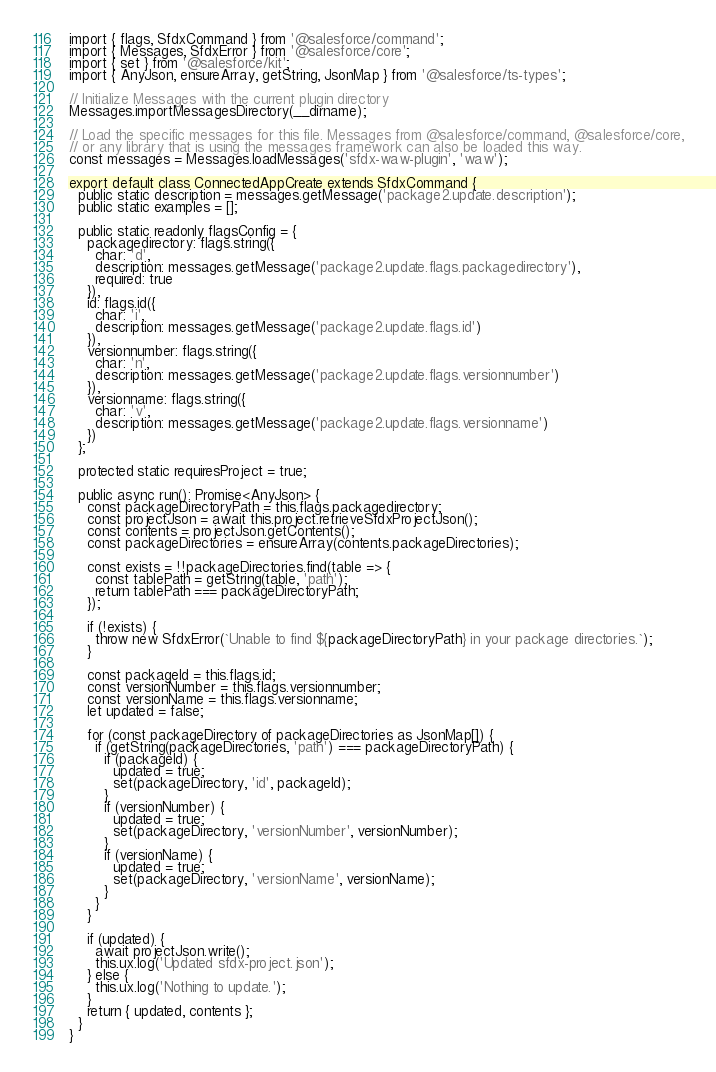<code> <loc_0><loc_0><loc_500><loc_500><_TypeScript_>import { flags, SfdxCommand } from '@salesforce/command';
import { Messages, SfdxError } from '@salesforce/core';
import { set } from '@salesforce/kit';
import { AnyJson, ensureArray, getString, JsonMap } from '@salesforce/ts-types';

// Initialize Messages with the current plugin directory
Messages.importMessagesDirectory(__dirname);

// Load the specific messages for this file. Messages from @salesforce/command, @salesforce/core,
// or any library that is using the messages framework can also be loaded this way.
const messages = Messages.loadMessages('sfdx-waw-plugin', 'waw');

export default class ConnectedAppCreate extends SfdxCommand {
  public static description = messages.getMessage('package2.update.description');
  public static examples = [];

  public static readonly flagsConfig = {
    packagedirectory: flags.string({
      char: 'd',
      description: messages.getMessage('package2.update.flags.packagedirectory'),
      required: true
    }),
    id: flags.id({
      char: 'i',
      description: messages.getMessage('package2.update.flags.id')
    }),
    versionnumber: flags.string({
      char: 'n',
      description: messages.getMessage('package2.update.flags.versionnumber')
    }),
    versionname: flags.string({
      char: 'v',
      description: messages.getMessage('package2.update.flags.versionname')
    })
  };

  protected static requiresProject = true;

  public async run(): Promise<AnyJson> {
    const packageDirectoryPath = this.flags.packagedirectory;
    const projectJson = await this.project.retrieveSfdxProjectJson();
    const contents = projectJson.getContents();
    const packageDirectories = ensureArray(contents.packageDirectories);

    const exists = !!packageDirectories.find(table => {
      const tablePath = getString(table, 'path');
      return tablePath === packageDirectoryPath;
    });

    if (!exists) {
      throw new SfdxError(`Unable to find ${packageDirectoryPath} in your package directories.`);
    }

    const packageId = this.flags.id;
    const versionNumber = this.flags.versionnumber;
    const versionName = this.flags.versionname;
    let updated = false;

    for (const packageDirectory of packageDirectories as JsonMap[]) {
      if (getString(packageDirectories, 'path') === packageDirectoryPath) {
        if (packageId) {
          updated = true;
          set(packageDirectory, 'id', packageId);
        }
        if (versionNumber) {
          updated = true;
          set(packageDirectory, 'versionNumber', versionNumber);
        }
        if (versionName) {
          updated = true;
          set(packageDirectory, 'versionName', versionName);
        }
      }
    }

    if (updated) {
      await projectJson.write();
      this.ux.log('Updated sfdx-project.json');
    } else {
      this.ux.log('Nothing to update.');
    }
    return { updated, contents };
  }
}
</code> 